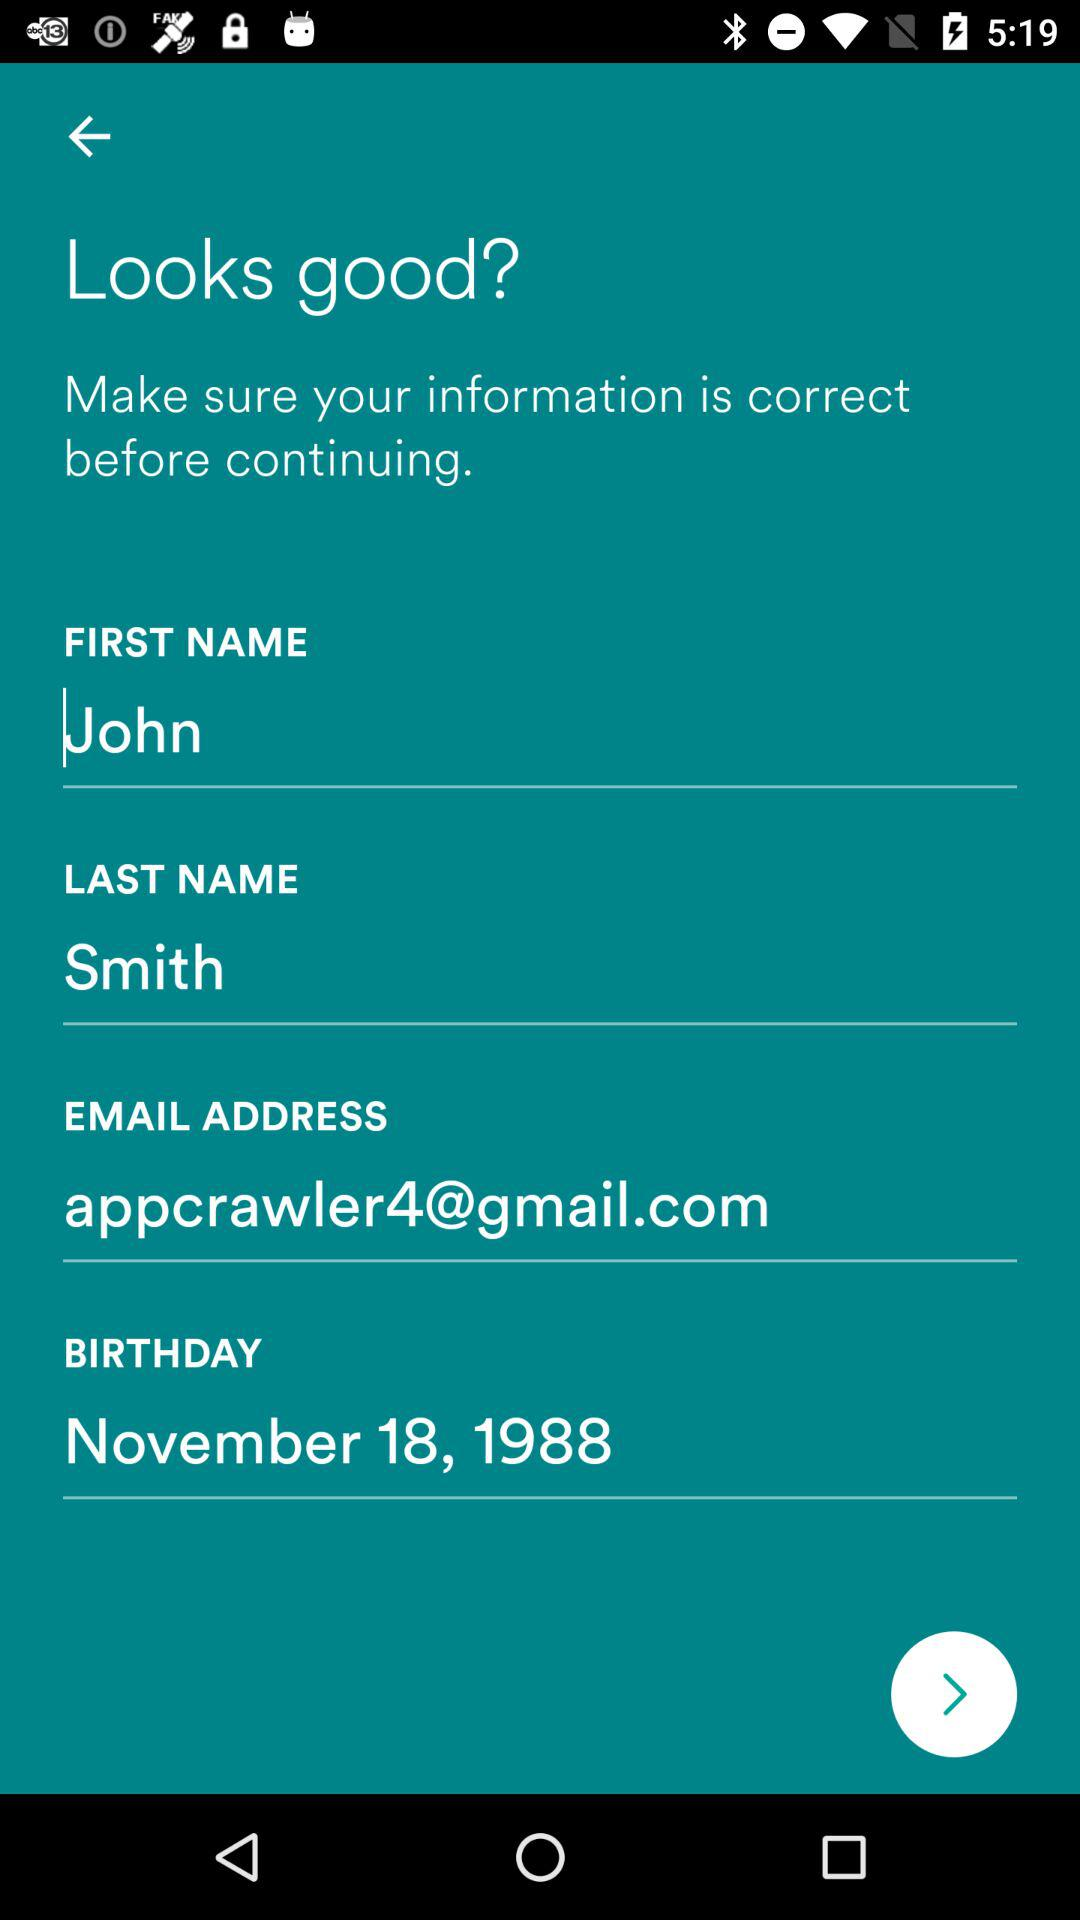What is the first name? The first name is John. 